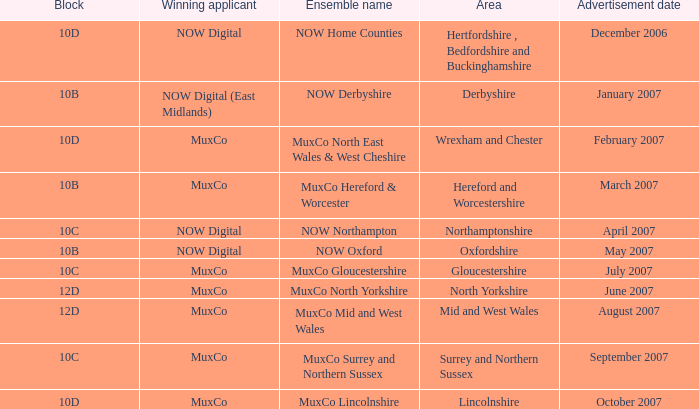Which Block does Northamptonshire Area have? 10C. 